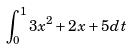Convert formula to latex. <formula><loc_0><loc_0><loc_500><loc_500>\int _ { 0 } ^ { 1 } 3 x ^ { 2 } + 2 x + 5 d t</formula> 